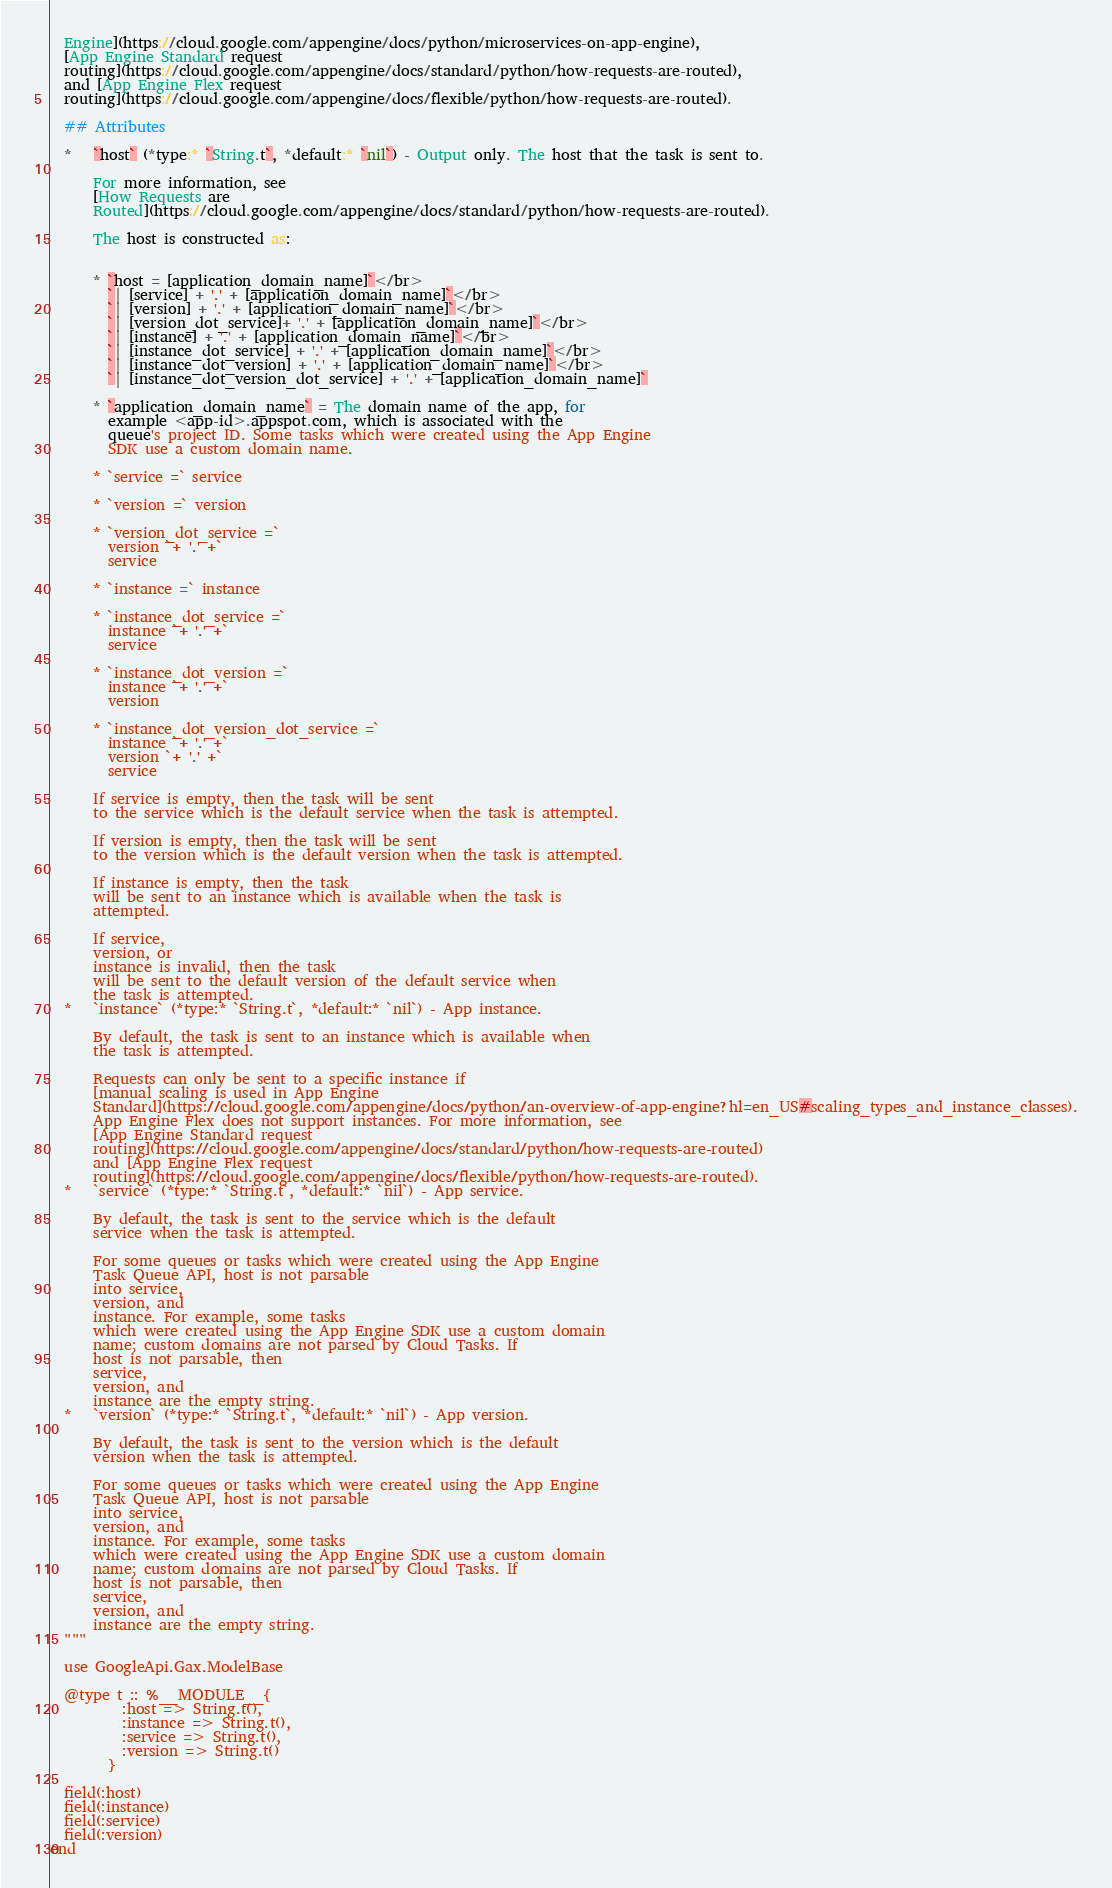Convert code to text. <code><loc_0><loc_0><loc_500><loc_500><_Elixir_>  Engine](https://cloud.google.com/appengine/docs/python/microservices-on-app-engine),
  [App Engine Standard request
  routing](https://cloud.google.com/appengine/docs/standard/python/how-requests-are-routed),
  and [App Engine Flex request
  routing](https://cloud.google.com/appengine/docs/flexible/python/how-requests-are-routed).

  ## Attributes

  *   `host` (*type:* `String.t`, *default:* `nil`) - Output only. The host that the task is sent to.

      For more information, see
      [How Requests are
      Routed](https://cloud.google.com/appengine/docs/standard/python/how-requests-are-routed).

      The host is constructed as:


      * `host = [application_domain_name]`</br>
        `| [service] + '.' + [application_domain_name]`</br>
        `| [version] + '.' + [application_domain_name]`</br>
        `| [version_dot_service]+ '.' + [application_domain_name]`</br>
        `| [instance] + '.' + [application_domain_name]`</br>
        `| [instance_dot_service] + '.' + [application_domain_name]`</br>
        `| [instance_dot_version] + '.' + [application_domain_name]`</br>
        `| [instance_dot_version_dot_service] + '.' + [application_domain_name]`

      * `application_domain_name` = The domain name of the app, for
        example <app-id>.appspot.com, which is associated with the
        queue's project ID. Some tasks which were created using the App Engine
        SDK use a custom domain name.

      * `service =` service

      * `version =` version

      * `version_dot_service =`
        version `+ '.' +`
        service

      * `instance =` instance

      * `instance_dot_service =`
        instance `+ '.' +`
        service

      * `instance_dot_version =`
        instance `+ '.' +`
        version

      * `instance_dot_version_dot_service =`
        instance `+ '.' +`
        version `+ '.' +`
        service

      If service is empty, then the task will be sent
      to the service which is the default service when the task is attempted.

      If version is empty, then the task will be sent
      to the version which is the default version when the task is attempted.

      If instance is empty, then the task
      will be sent to an instance which is available when the task is
      attempted.

      If service,
      version, or
      instance is invalid, then the task
      will be sent to the default version of the default service when
      the task is attempted.
  *   `instance` (*type:* `String.t`, *default:* `nil`) - App instance.

      By default, the task is sent to an instance which is available when
      the task is attempted.

      Requests can only be sent to a specific instance if
      [manual scaling is used in App Engine
      Standard](https://cloud.google.com/appengine/docs/python/an-overview-of-app-engine?hl=en_US#scaling_types_and_instance_classes).
      App Engine Flex does not support instances. For more information, see
      [App Engine Standard request
      routing](https://cloud.google.com/appengine/docs/standard/python/how-requests-are-routed)
      and [App Engine Flex request
      routing](https://cloud.google.com/appengine/docs/flexible/python/how-requests-are-routed).
  *   `service` (*type:* `String.t`, *default:* `nil`) - App service.

      By default, the task is sent to the service which is the default
      service when the task is attempted.

      For some queues or tasks which were created using the App Engine
      Task Queue API, host is not parsable
      into service,
      version, and
      instance. For example, some tasks
      which were created using the App Engine SDK use a custom domain
      name; custom domains are not parsed by Cloud Tasks. If
      host is not parsable, then
      service,
      version, and
      instance are the empty string.
  *   `version` (*type:* `String.t`, *default:* `nil`) - App version.

      By default, the task is sent to the version which is the default
      version when the task is attempted.

      For some queues or tasks which were created using the App Engine
      Task Queue API, host is not parsable
      into service,
      version, and
      instance. For example, some tasks
      which were created using the App Engine SDK use a custom domain
      name; custom domains are not parsed by Cloud Tasks. If
      host is not parsable, then
      service,
      version, and
      instance are the empty string.
  """

  use GoogleApi.Gax.ModelBase

  @type t :: %__MODULE__{
          :host => String.t(),
          :instance => String.t(),
          :service => String.t(),
          :version => String.t()
        }

  field(:host)
  field(:instance)
  field(:service)
  field(:version)
end
</code> 